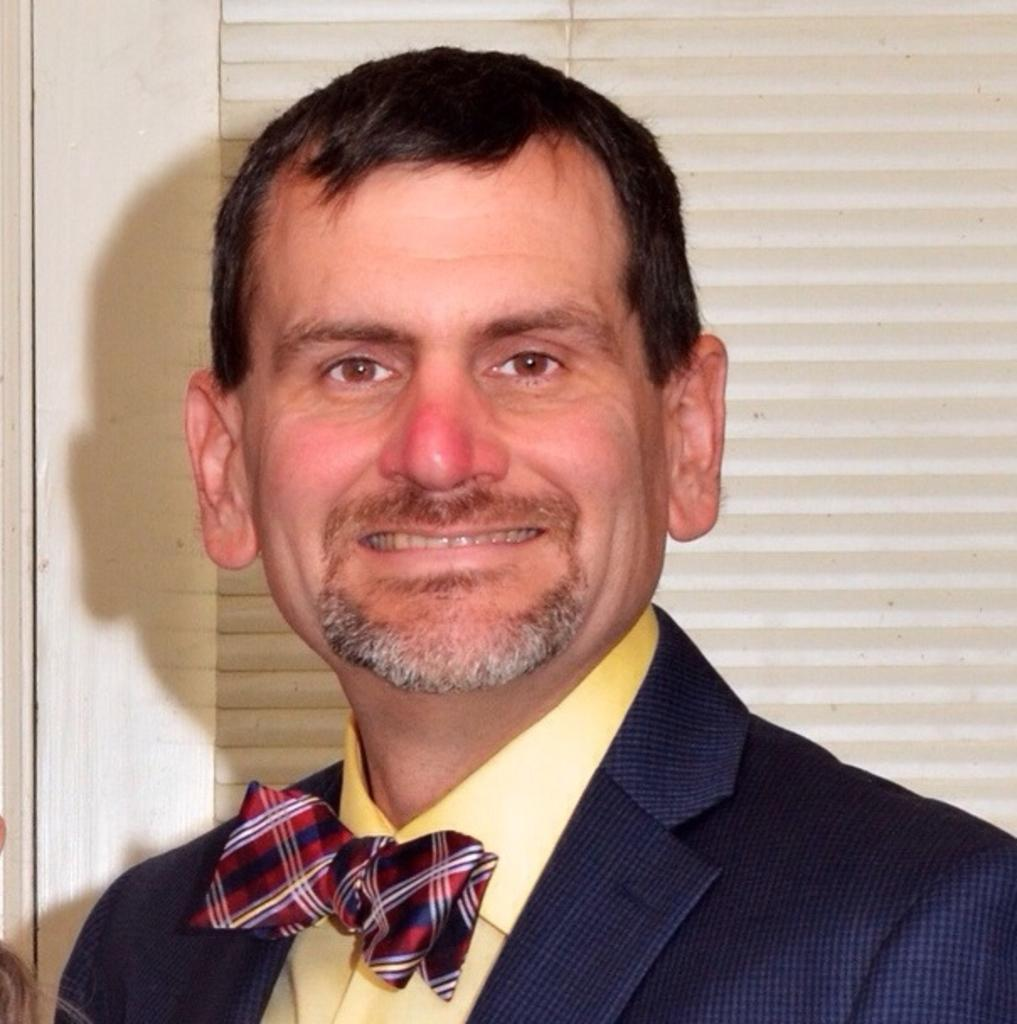What is present in the image? There is a man in the image. Can you describe the man's expression? The man is smiling. What type of pest can be seen crawling on the man's shoulder in the image? There is no pest present on the man's shoulder in the image. What route is the man taking in the image? The image does not show the man taking any specific route. What song is the man singing in the image? The image does not show the man singing any song. 